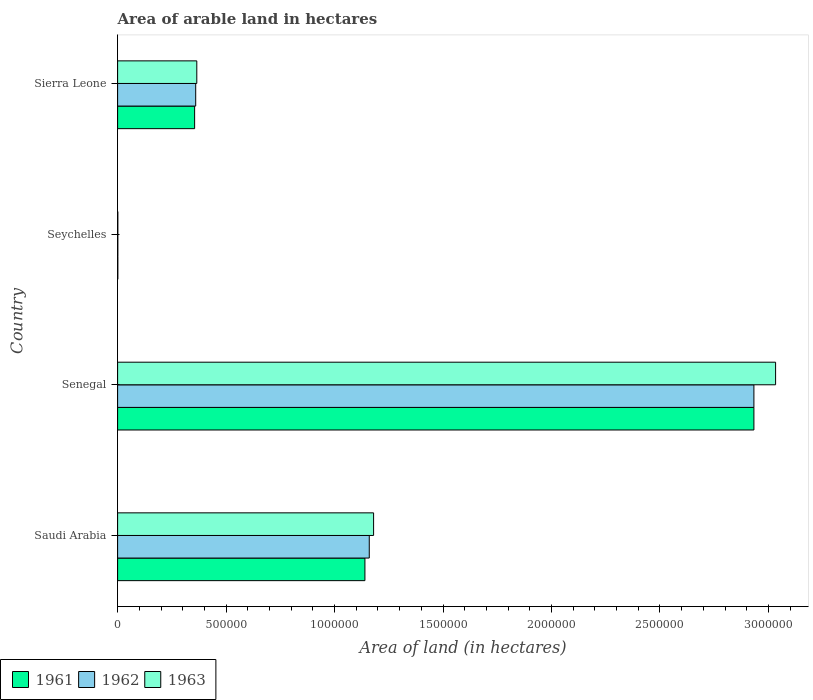How many different coloured bars are there?
Offer a very short reply. 3. How many bars are there on the 2nd tick from the top?
Ensure brevity in your answer.  3. What is the label of the 4th group of bars from the top?
Provide a short and direct response. Saudi Arabia. What is the total arable land in 1963 in Senegal?
Your answer should be compact. 3.03e+06. Across all countries, what is the maximum total arable land in 1961?
Provide a succinct answer. 2.93e+06. Across all countries, what is the minimum total arable land in 1963?
Your answer should be compact. 1000. In which country was the total arable land in 1963 maximum?
Offer a terse response. Senegal. In which country was the total arable land in 1962 minimum?
Provide a succinct answer. Seychelles. What is the total total arable land in 1961 in the graph?
Provide a succinct answer. 4.43e+06. What is the difference between the total arable land in 1961 in Senegal and that in Seychelles?
Your response must be concise. 2.93e+06. What is the difference between the total arable land in 1962 in Saudi Arabia and the total arable land in 1963 in Seychelles?
Your answer should be compact. 1.16e+06. What is the average total arable land in 1962 per country?
Make the answer very short. 1.11e+06. What is the difference between the total arable land in 1962 and total arable land in 1961 in Senegal?
Ensure brevity in your answer.  0. What is the ratio of the total arable land in 1963 in Senegal to that in Sierra Leone?
Give a very brief answer. 8.31. Is the difference between the total arable land in 1962 in Saudi Arabia and Senegal greater than the difference between the total arable land in 1961 in Saudi Arabia and Senegal?
Give a very brief answer. Yes. What is the difference between the highest and the second highest total arable land in 1962?
Make the answer very short. 1.77e+06. What is the difference between the highest and the lowest total arable land in 1963?
Ensure brevity in your answer.  3.03e+06. Is the sum of the total arable land in 1961 in Saudi Arabia and Senegal greater than the maximum total arable land in 1963 across all countries?
Your answer should be very brief. Yes. What does the 1st bar from the bottom in Sierra Leone represents?
Offer a very short reply. 1961. Is it the case that in every country, the sum of the total arable land in 1961 and total arable land in 1962 is greater than the total arable land in 1963?
Offer a very short reply. Yes. How many bars are there?
Your response must be concise. 12. Does the graph contain grids?
Your response must be concise. No. Where does the legend appear in the graph?
Make the answer very short. Bottom left. What is the title of the graph?
Offer a very short reply. Area of arable land in hectares. What is the label or title of the X-axis?
Give a very brief answer. Area of land (in hectares). What is the label or title of the Y-axis?
Provide a succinct answer. Country. What is the Area of land (in hectares) in 1961 in Saudi Arabia?
Provide a short and direct response. 1.14e+06. What is the Area of land (in hectares) in 1962 in Saudi Arabia?
Make the answer very short. 1.16e+06. What is the Area of land (in hectares) in 1963 in Saudi Arabia?
Keep it short and to the point. 1.18e+06. What is the Area of land (in hectares) of 1961 in Senegal?
Your answer should be compact. 2.93e+06. What is the Area of land (in hectares) of 1962 in Senegal?
Make the answer very short. 2.93e+06. What is the Area of land (in hectares) of 1963 in Senegal?
Your response must be concise. 3.03e+06. What is the Area of land (in hectares) of 1961 in Seychelles?
Keep it short and to the point. 1000. What is the Area of land (in hectares) of 1962 in Seychelles?
Ensure brevity in your answer.  1000. What is the Area of land (in hectares) in 1963 in Seychelles?
Your answer should be very brief. 1000. What is the Area of land (in hectares) of 1961 in Sierra Leone?
Offer a terse response. 3.55e+05. What is the Area of land (in hectares) of 1963 in Sierra Leone?
Keep it short and to the point. 3.65e+05. Across all countries, what is the maximum Area of land (in hectares) of 1961?
Offer a very short reply. 2.93e+06. Across all countries, what is the maximum Area of land (in hectares) of 1962?
Make the answer very short. 2.93e+06. Across all countries, what is the maximum Area of land (in hectares) of 1963?
Provide a short and direct response. 3.03e+06. Across all countries, what is the minimum Area of land (in hectares) in 1961?
Provide a short and direct response. 1000. Across all countries, what is the minimum Area of land (in hectares) of 1962?
Provide a succinct answer. 1000. What is the total Area of land (in hectares) in 1961 in the graph?
Offer a very short reply. 4.43e+06. What is the total Area of land (in hectares) of 1962 in the graph?
Make the answer very short. 4.45e+06. What is the total Area of land (in hectares) of 1963 in the graph?
Make the answer very short. 4.58e+06. What is the difference between the Area of land (in hectares) of 1961 in Saudi Arabia and that in Senegal?
Keep it short and to the point. -1.79e+06. What is the difference between the Area of land (in hectares) in 1962 in Saudi Arabia and that in Senegal?
Keep it short and to the point. -1.77e+06. What is the difference between the Area of land (in hectares) in 1963 in Saudi Arabia and that in Senegal?
Keep it short and to the point. -1.85e+06. What is the difference between the Area of land (in hectares) in 1961 in Saudi Arabia and that in Seychelles?
Make the answer very short. 1.14e+06. What is the difference between the Area of land (in hectares) of 1962 in Saudi Arabia and that in Seychelles?
Your answer should be very brief. 1.16e+06. What is the difference between the Area of land (in hectares) in 1963 in Saudi Arabia and that in Seychelles?
Your answer should be very brief. 1.18e+06. What is the difference between the Area of land (in hectares) in 1961 in Saudi Arabia and that in Sierra Leone?
Ensure brevity in your answer.  7.85e+05. What is the difference between the Area of land (in hectares) in 1962 in Saudi Arabia and that in Sierra Leone?
Give a very brief answer. 8.00e+05. What is the difference between the Area of land (in hectares) in 1963 in Saudi Arabia and that in Sierra Leone?
Provide a succinct answer. 8.15e+05. What is the difference between the Area of land (in hectares) in 1961 in Senegal and that in Seychelles?
Your response must be concise. 2.93e+06. What is the difference between the Area of land (in hectares) in 1962 in Senegal and that in Seychelles?
Offer a very short reply. 2.93e+06. What is the difference between the Area of land (in hectares) in 1963 in Senegal and that in Seychelles?
Provide a short and direct response. 3.03e+06. What is the difference between the Area of land (in hectares) in 1961 in Senegal and that in Sierra Leone?
Your answer should be very brief. 2.58e+06. What is the difference between the Area of land (in hectares) in 1962 in Senegal and that in Sierra Leone?
Offer a very short reply. 2.57e+06. What is the difference between the Area of land (in hectares) in 1963 in Senegal and that in Sierra Leone?
Your answer should be very brief. 2.67e+06. What is the difference between the Area of land (in hectares) of 1961 in Seychelles and that in Sierra Leone?
Your answer should be very brief. -3.54e+05. What is the difference between the Area of land (in hectares) in 1962 in Seychelles and that in Sierra Leone?
Ensure brevity in your answer.  -3.59e+05. What is the difference between the Area of land (in hectares) of 1963 in Seychelles and that in Sierra Leone?
Your answer should be compact. -3.64e+05. What is the difference between the Area of land (in hectares) in 1961 in Saudi Arabia and the Area of land (in hectares) in 1962 in Senegal?
Make the answer very short. -1.79e+06. What is the difference between the Area of land (in hectares) of 1961 in Saudi Arabia and the Area of land (in hectares) of 1963 in Senegal?
Your response must be concise. -1.89e+06. What is the difference between the Area of land (in hectares) of 1962 in Saudi Arabia and the Area of land (in hectares) of 1963 in Senegal?
Make the answer very short. -1.87e+06. What is the difference between the Area of land (in hectares) of 1961 in Saudi Arabia and the Area of land (in hectares) of 1962 in Seychelles?
Provide a short and direct response. 1.14e+06. What is the difference between the Area of land (in hectares) in 1961 in Saudi Arabia and the Area of land (in hectares) in 1963 in Seychelles?
Offer a very short reply. 1.14e+06. What is the difference between the Area of land (in hectares) in 1962 in Saudi Arabia and the Area of land (in hectares) in 1963 in Seychelles?
Offer a terse response. 1.16e+06. What is the difference between the Area of land (in hectares) of 1961 in Saudi Arabia and the Area of land (in hectares) of 1962 in Sierra Leone?
Provide a short and direct response. 7.80e+05. What is the difference between the Area of land (in hectares) in 1961 in Saudi Arabia and the Area of land (in hectares) in 1963 in Sierra Leone?
Your answer should be very brief. 7.75e+05. What is the difference between the Area of land (in hectares) in 1962 in Saudi Arabia and the Area of land (in hectares) in 1963 in Sierra Leone?
Give a very brief answer. 7.95e+05. What is the difference between the Area of land (in hectares) in 1961 in Senegal and the Area of land (in hectares) in 1962 in Seychelles?
Ensure brevity in your answer.  2.93e+06. What is the difference between the Area of land (in hectares) in 1961 in Senegal and the Area of land (in hectares) in 1963 in Seychelles?
Your response must be concise. 2.93e+06. What is the difference between the Area of land (in hectares) in 1962 in Senegal and the Area of land (in hectares) in 1963 in Seychelles?
Ensure brevity in your answer.  2.93e+06. What is the difference between the Area of land (in hectares) in 1961 in Senegal and the Area of land (in hectares) in 1962 in Sierra Leone?
Give a very brief answer. 2.57e+06. What is the difference between the Area of land (in hectares) of 1961 in Senegal and the Area of land (in hectares) of 1963 in Sierra Leone?
Make the answer very short. 2.57e+06. What is the difference between the Area of land (in hectares) in 1962 in Senegal and the Area of land (in hectares) in 1963 in Sierra Leone?
Keep it short and to the point. 2.57e+06. What is the difference between the Area of land (in hectares) of 1961 in Seychelles and the Area of land (in hectares) of 1962 in Sierra Leone?
Offer a terse response. -3.59e+05. What is the difference between the Area of land (in hectares) in 1961 in Seychelles and the Area of land (in hectares) in 1963 in Sierra Leone?
Your response must be concise. -3.64e+05. What is the difference between the Area of land (in hectares) of 1962 in Seychelles and the Area of land (in hectares) of 1963 in Sierra Leone?
Provide a succinct answer. -3.64e+05. What is the average Area of land (in hectares) in 1961 per country?
Provide a succinct answer. 1.11e+06. What is the average Area of land (in hectares) of 1962 per country?
Provide a succinct answer. 1.11e+06. What is the average Area of land (in hectares) in 1963 per country?
Your answer should be compact. 1.14e+06. What is the difference between the Area of land (in hectares) in 1961 and Area of land (in hectares) in 1962 in Saudi Arabia?
Your answer should be compact. -2.00e+04. What is the difference between the Area of land (in hectares) in 1961 and Area of land (in hectares) in 1963 in Saudi Arabia?
Offer a very short reply. -4.00e+04. What is the difference between the Area of land (in hectares) of 1962 and Area of land (in hectares) of 1963 in Saudi Arabia?
Your response must be concise. -2.00e+04. What is the difference between the Area of land (in hectares) of 1961 and Area of land (in hectares) of 1962 in Senegal?
Give a very brief answer. 0. What is the difference between the Area of land (in hectares) of 1961 and Area of land (in hectares) of 1963 in Senegal?
Offer a very short reply. -1.00e+05. What is the difference between the Area of land (in hectares) in 1961 and Area of land (in hectares) in 1963 in Seychelles?
Your answer should be very brief. 0. What is the difference between the Area of land (in hectares) of 1961 and Area of land (in hectares) of 1962 in Sierra Leone?
Keep it short and to the point. -5000. What is the difference between the Area of land (in hectares) in 1962 and Area of land (in hectares) in 1963 in Sierra Leone?
Your answer should be compact. -5000. What is the ratio of the Area of land (in hectares) of 1961 in Saudi Arabia to that in Senegal?
Ensure brevity in your answer.  0.39. What is the ratio of the Area of land (in hectares) of 1962 in Saudi Arabia to that in Senegal?
Your answer should be compact. 0.4. What is the ratio of the Area of land (in hectares) of 1963 in Saudi Arabia to that in Senegal?
Provide a succinct answer. 0.39. What is the ratio of the Area of land (in hectares) of 1961 in Saudi Arabia to that in Seychelles?
Provide a short and direct response. 1140. What is the ratio of the Area of land (in hectares) in 1962 in Saudi Arabia to that in Seychelles?
Provide a short and direct response. 1160. What is the ratio of the Area of land (in hectares) in 1963 in Saudi Arabia to that in Seychelles?
Make the answer very short. 1180. What is the ratio of the Area of land (in hectares) in 1961 in Saudi Arabia to that in Sierra Leone?
Your response must be concise. 3.21. What is the ratio of the Area of land (in hectares) in 1962 in Saudi Arabia to that in Sierra Leone?
Provide a short and direct response. 3.22. What is the ratio of the Area of land (in hectares) of 1963 in Saudi Arabia to that in Sierra Leone?
Provide a short and direct response. 3.23. What is the ratio of the Area of land (in hectares) of 1961 in Senegal to that in Seychelles?
Give a very brief answer. 2933. What is the ratio of the Area of land (in hectares) in 1962 in Senegal to that in Seychelles?
Your response must be concise. 2933. What is the ratio of the Area of land (in hectares) of 1963 in Senegal to that in Seychelles?
Your answer should be compact. 3033. What is the ratio of the Area of land (in hectares) of 1961 in Senegal to that in Sierra Leone?
Your answer should be very brief. 8.26. What is the ratio of the Area of land (in hectares) in 1962 in Senegal to that in Sierra Leone?
Provide a succinct answer. 8.15. What is the ratio of the Area of land (in hectares) in 1963 in Senegal to that in Sierra Leone?
Ensure brevity in your answer.  8.31. What is the ratio of the Area of land (in hectares) of 1961 in Seychelles to that in Sierra Leone?
Provide a succinct answer. 0. What is the ratio of the Area of land (in hectares) of 1962 in Seychelles to that in Sierra Leone?
Make the answer very short. 0. What is the ratio of the Area of land (in hectares) of 1963 in Seychelles to that in Sierra Leone?
Keep it short and to the point. 0. What is the difference between the highest and the second highest Area of land (in hectares) in 1961?
Make the answer very short. 1.79e+06. What is the difference between the highest and the second highest Area of land (in hectares) in 1962?
Offer a very short reply. 1.77e+06. What is the difference between the highest and the second highest Area of land (in hectares) in 1963?
Your answer should be compact. 1.85e+06. What is the difference between the highest and the lowest Area of land (in hectares) in 1961?
Your response must be concise. 2.93e+06. What is the difference between the highest and the lowest Area of land (in hectares) in 1962?
Provide a succinct answer. 2.93e+06. What is the difference between the highest and the lowest Area of land (in hectares) in 1963?
Give a very brief answer. 3.03e+06. 